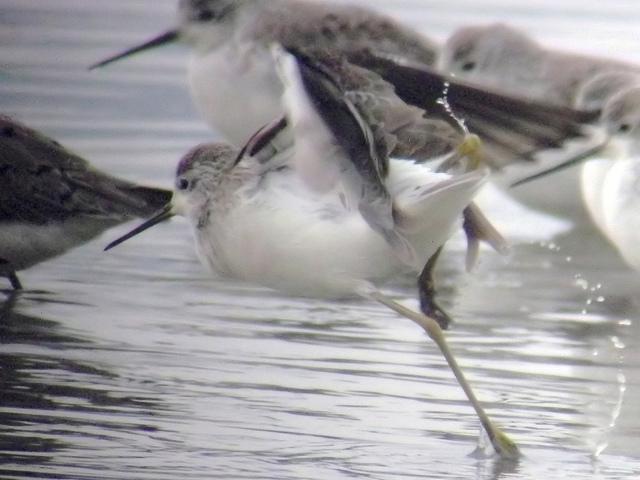Is this a flock?
Write a very short answer. Yes. What color are the birds?
Short answer required. White and gray. What are those birds doing?
Answer briefly. Flying. 